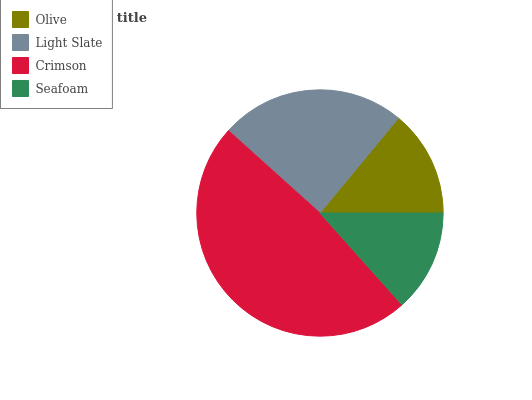Is Seafoam the minimum?
Answer yes or no. Yes. Is Crimson the maximum?
Answer yes or no. Yes. Is Light Slate the minimum?
Answer yes or no. No. Is Light Slate the maximum?
Answer yes or no. No. Is Light Slate greater than Olive?
Answer yes or no. Yes. Is Olive less than Light Slate?
Answer yes or no. Yes. Is Olive greater than Light Slate?
Answer yes or no. No. Is Light Slate less than Olive?
Answer yes or no. No. Is Light Slate the high median?
Answer yes or no. Yes. Is Olive the low median?
Answer yes or no. Yes. Is Olive the high median?
Answer yes or no. No. Is Seafoam the low median?
Answer yes or no. No. 